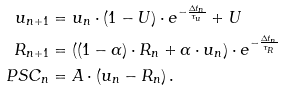Convert formula to latex. <formula><loc_0><loc_0><loc_500><loc_500>u _ { n + 1 } & = u _ { n } \cdot ( 1 - U ) \cdot e ^ { - \frac { \Delta t _ { n } } { \tau _ { u } } } + U \\ R _ { n + 1 } & = \left ( ( 1 - \alpha ) \cdot R _ { n } + \alpha \cdot u _ { n } \right ) \cdot e ^ { - \frac { \Delta t _ { n } } { \tau _ { R } } } \\ P S C _ { n } & = A \cdot ( u _ { n } - R _ { n } ) \, .</formula> 